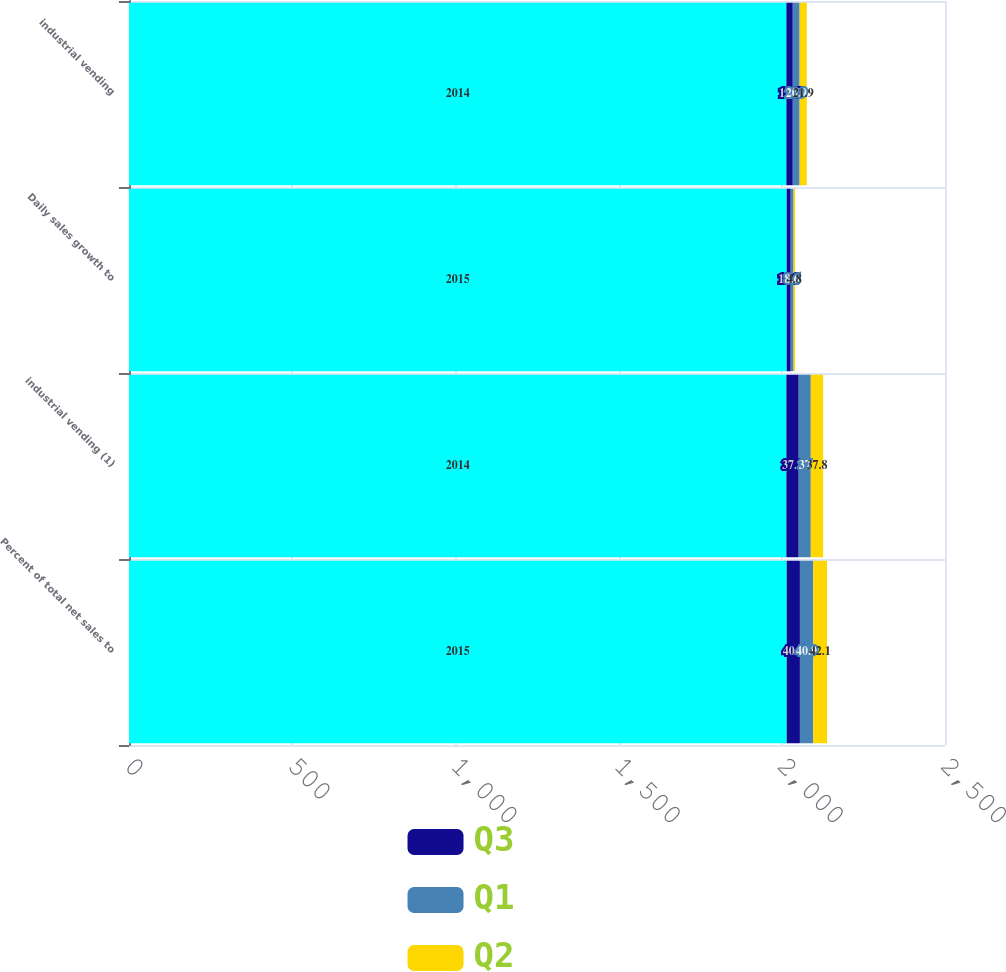Convert chart to OTSL. <chart><loc_0><loc_0><loc_500><loc_500><stacked_bar_chart><ecel><fcel>Percent of total net sales to<fcel>industrial vending (1)<fcel>Daily sales growth to<fcel>industrial vending<nl><fcel>nan<fcel>2015<fcel>2014<fcel>2015<fcel>2014<nl><fcel>Q3<fcel>40.5<fcel>37.8<fcel>12.3<fcel>19.7<nl><fcel>Q1<fcel>40.9<fcel>37<fcel>8.6<fcel>20.9<nl><fcel>Q2<fcel>42.1<fcel>37.8<fcel>4.8<fcel>21.9<nl></chart> 